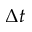<formula> <loc_0><loc_0><loc_500><loc_500>\Delta t</formula> 